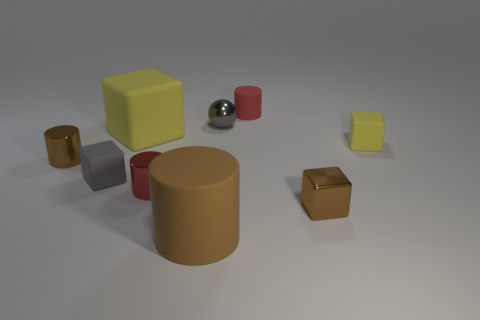Subtract all gray blocks. How many blocks are left? 3 Subtract all small yellow rubber cubes. How many cubes are left? 3 Subtract 2 blocks. How many blocks are left? 2 Subtract all purple blocks. Subtract all blue cylinders. How many blocks are left? 4 Add 1 big yellow matte cubes. How many objects exist? 10 Subtract all cylinders. How many objects are left? 5 Add 5 tiny red matte objects. How many tiny red matte objects are left? 6 Add 7 green metallic blocks. How many green metallic blocks exist? 7 Subtract 0 cyan balls. How many objects are left? 9 Subtract all tiny brown cylinders. Subtract all metal things. How many objects are left? 4 